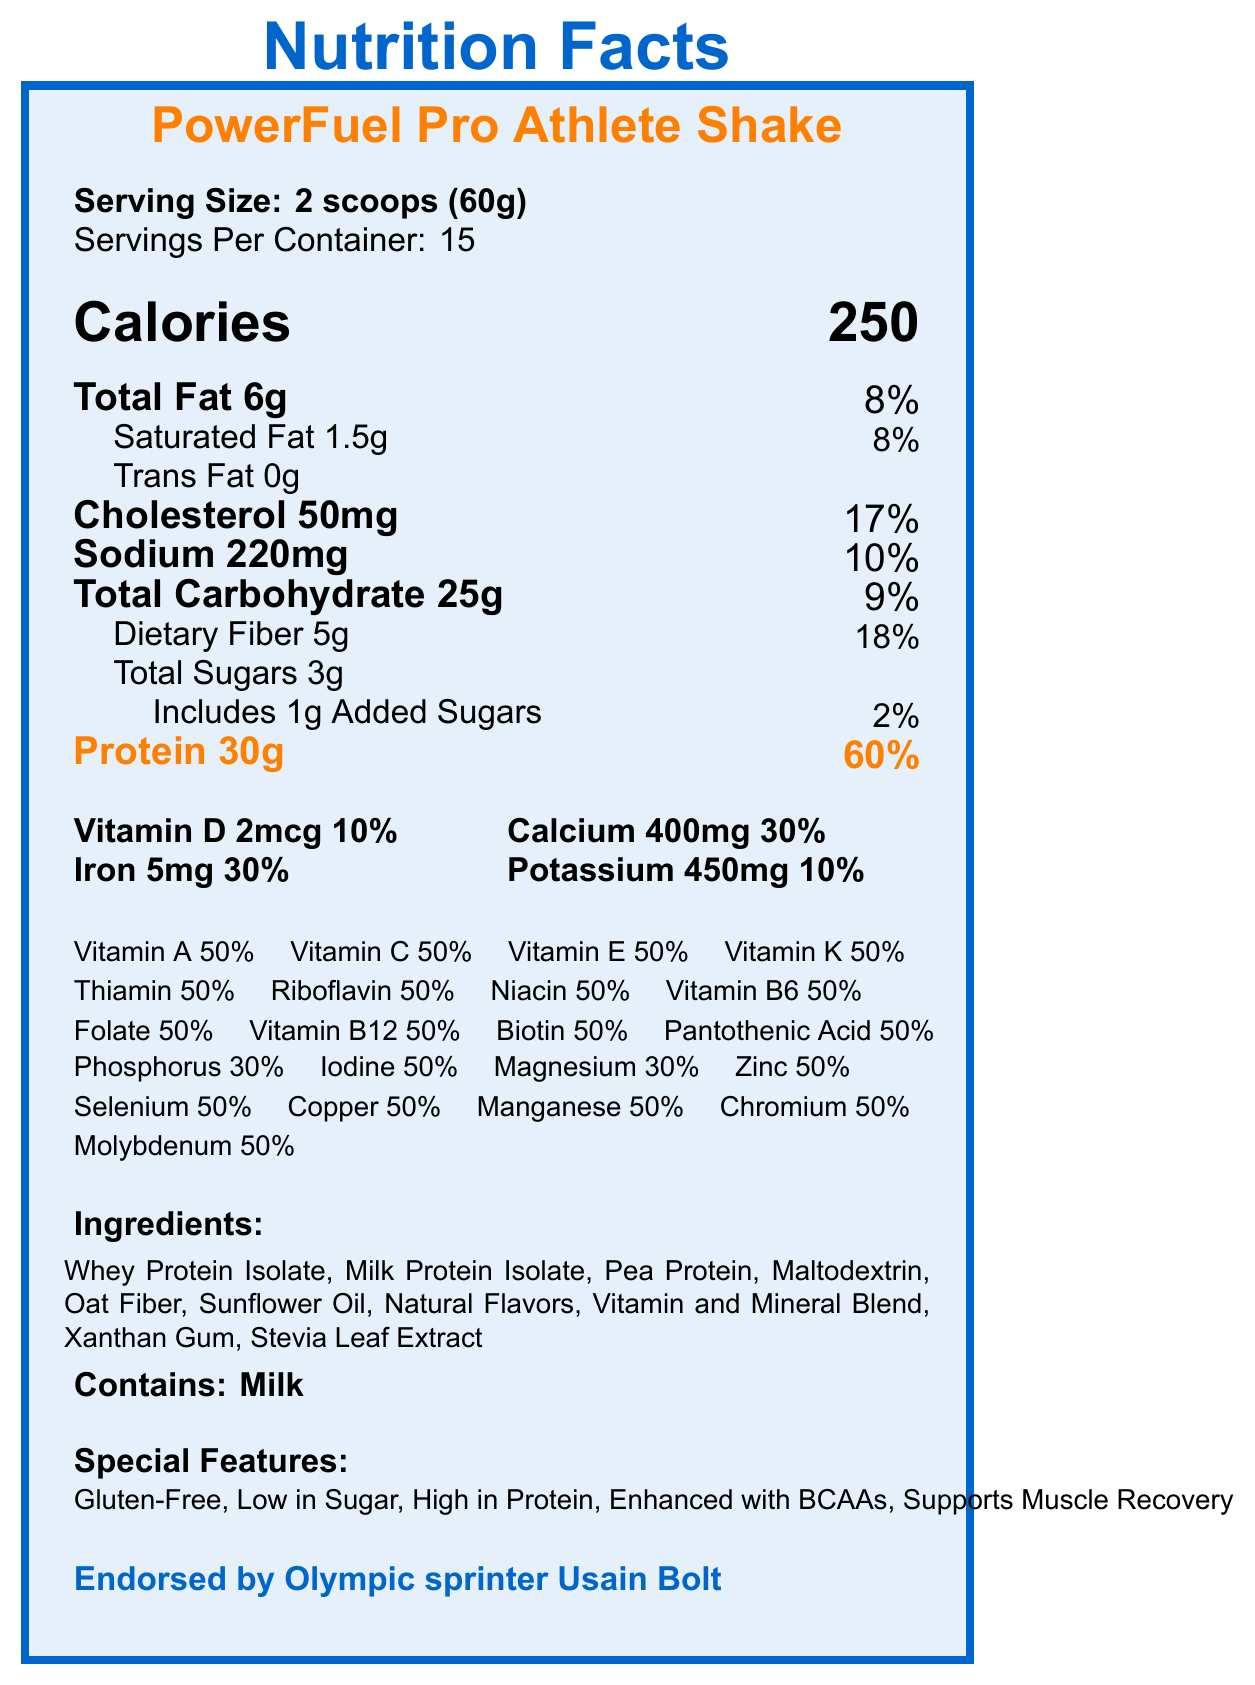What is the serving size for the PowerFuel Pro Athlete Shake? The serving size is stated as "2 scoops (60g)" under Serving Size in the document.
Answer: 2 scoops (60g) How many servings are there per container? The Servings Per Container is listed as 15 in the document.
Answer: 15 What is the percentage of daily value for protein in each serving? The document states that Protein 30g corresponds to 60% of the daily value.
Answer: 60% Which special feature indicates the shake is suitable for those avoiding gluten? The Special Features section lists "Gluten-Free" as one of its properties.
Answer: Gluten-Free What is the total amount of cholesterol per serving? The document lists the total amount of cholesterol per serving as 50mg.
Answer: 50mg How many grams of total sugars are there in each serving? A. 1g B. 2g C. 3g D. 4g The document indicates Total Sugars is 3g under the Macronutrients section.
Answer: C. 3g Which vitamin has the highest daily value percentage in the shake? A. Vitamin A B. Vitamin D C. Vitamin C D. Vitamin E Vitamin A has the highest daily value percentage listed at 50%, other vitamins also share the same percentage only multiple vitamins have 50%.
Answer: A. Vitamin A Is the shake endorsed by any athlete? The document mentions that it is endorsed by Olympic sprinter Usain Bolt.
Answer: Yes Please summarize the nutrition content and features of the PowerFuel Pro Athlete Shake. The document provides information about serving size, nutritional values, vitamin and mineral content, special features, ingredients, allergens, directions for use, and athlete endorsement.
Answer: The PowerFuel Pro Athlete Shake is a high-protein meal replacement shake designed for athletes, offering 250 calories, 6g of total fat, 30g of protein per serving, and contains a variety of vitamins and minerals, including 50% daily value of Vitamins A, C, E, K, and multiple B vitamins. It is gluten-free, low in sugar, enhanced with BCAAs, and supports muscle recovery. The shake is endorsed by Usain Bolt. Are there any artificial sweeteners in the shake? The ingredient list mentions Stevia Leaf Extract, a natural sweetener, but does not specify if there are any artificial sweeteners.
Answer: Not enough information Which of the following nutrients contributes most to the caloric content per serving? A. Total Fat B. Total Carbohydrate C. Protein Protein has the highest percentage daily value at 60% and with 30g per serving, it contributes substantially to the caloric content, given its high concentration compared to fats and carbohydrates.
Answer: C. Protein What is the amount of calcium per serving, and its corresponding % daily value? The document lists Calcium as 400mg with a daily value percentage of 30%.
Answer: 400mg, 30% Does the product contain any trans fat? The document specifies Trans Fat as 0g.
Answer: No 